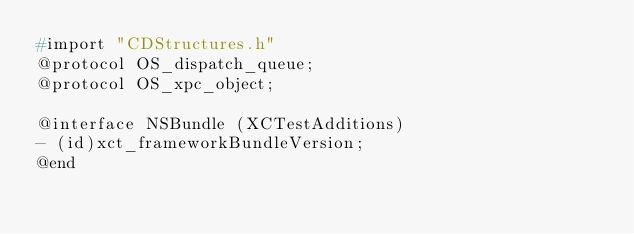Convert code to text. <code><loc_0><loc_0><loc_500><loc_500><_C_>#import "CDStructures.h"
@protocol OS_dispatch_queue;
@protocol OS_xpc_object;

@interface NSBundle (XCTestAdditions)
- (id)xct_frameworkBundleVersion;
@end

</code> 